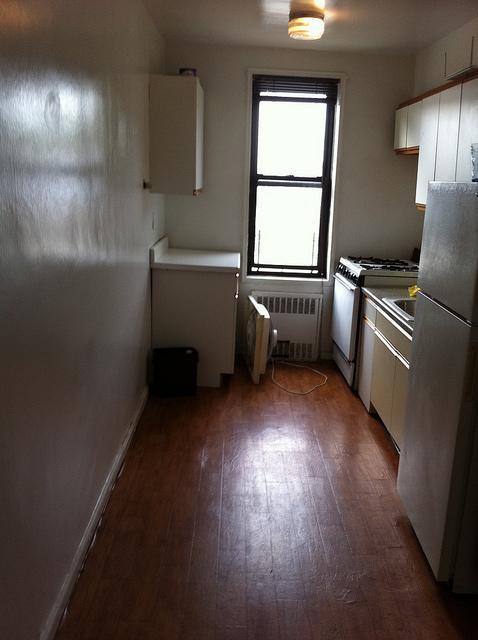How many ovens are there?
Give a very brief answer. 2. How many beds are there?
Give a very brief answer. 0. 